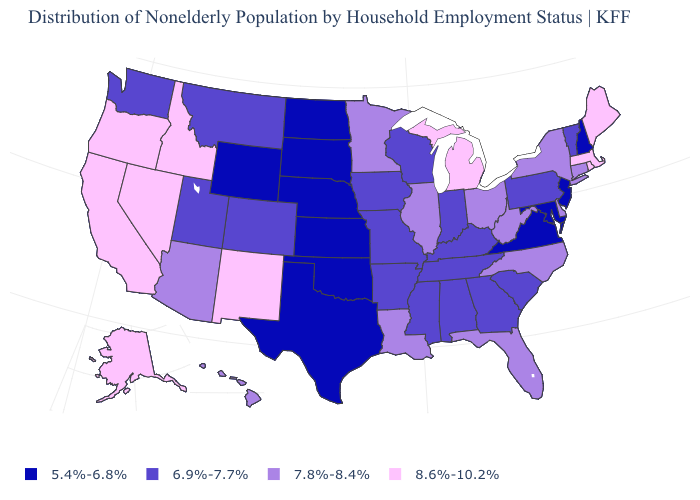Name the states that have a value in the range 5.4%-6.8%?
Give a very brief answer. Kansas, Maryland, Nebraska, New Hampshire, New Jersey, North Dakota, Oklahoma, South Dakota, Texas, Virginia, Wyoming. Name the states that have a value in the range 5.4%-6.8%?
Keep it brief. Kansas, Maryland, Nebraska, New Hampshire, New Jersey, North Dakota, Oklahoma, South Dakota, Texas, Virginia, Wyoming. What is the value of New York?
Answer briefly. 7.8%-8.4%. Name the states that have a value in the range 8.6%-10.2%?
Be succinct. Alaska, California, Idaho, Maine, Massachusetts, Michigan, Nevada, New Mexico, Oregon, Rhode Island. What is the value of Iowa?
Quick response, please. 6.9%-7.7%. Name the states that have a value in the range 6.9%-7.7%?
Answer briefly. Alabama, Arkansas, Colorado, Georgia, Indiana, Iowa, Kentucky, Mississippi, Missouri, Montana, Pennsylvania, South Carolina, Tennessee, Utah, Vermont, Washington, Wisconsin. Name the states that have a value in the range 7.8%-8.4%?
Short answer required. Arizona, Connecticut, Delaware, Florida, Hawaii, Illinois, Louisiana, Minnesota, New York, North Carolina, Ohio, West Virginia. Which states have the highest value in the USA?
Short answer required. Alaska, California, Idaho, Maine, Massachusetts, Michigan, Nevada, New Mexico, Oregon, Rhode Island. What is the value of Alabama?
Answer briefly. 6.9%-7.7%. What is the value of Ohio?
Give a very brief answer. 7.8%-8.4%. Does Massachusetts have the highest value in the USA?
Quick response, please. Yes. Name the states that have a value in the range 7.8%-8.4%?
Keep it brief. Arizona, Connecticut, Delaware, Florida, Hawaii, Illinois, Louisiana, Minnesota, New York, North Carolina, Ohio, West Virginia. What is the value of New Mexico?
Quick response, please. 8.6%-10.2%. What is the value of Colorado?
Be succinct. 6.9%-7.7%. What is the value of Pennsylvania?
Be succinct. 6.9%-7.7%. 